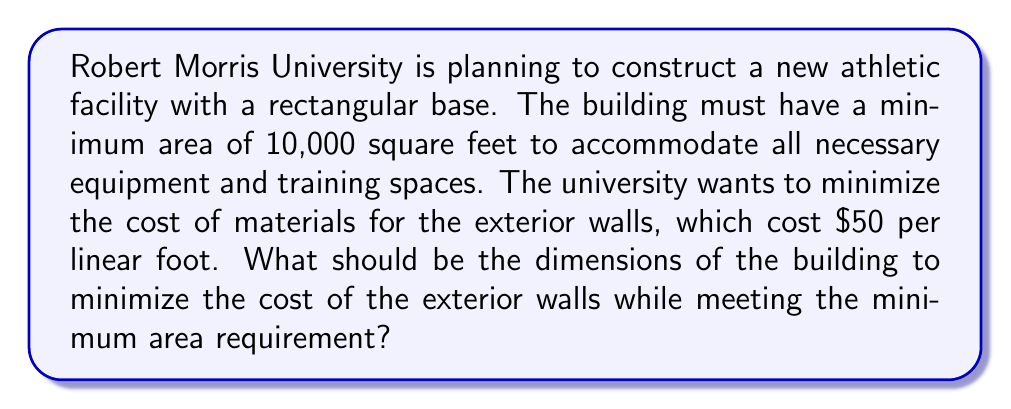Provide a solution to this math problem. Let's approach this step-by-step:

1) Let the length of the building be $l$ and the width be $w$.

2) The area constraint is:
   $$ A = l \cdot w \geq 10,000 \text{ sq ft} $$

3) The perimeter of the building (which determines the wall cost) is:
   $$ P = 2l + 2w $$

4) The cost function to minimize is:
   $$ C = 50P = 50(2l + 2w) = 100l + 100w $$

5) We want to minimize $C$ subject to the constraint $l \cdot w = 10,000$. 
   (We use equality here because the minimum will occur at the smallest possible area.)

6) We can use the method of Lagrange multipliers or substitute $w = \frac{10,000}{l}$ into the cost function:

   $$ C = 100l + 100(\frac{10,000}{l}) = 100l + \frac{1,000,000}{l} $$

7) To find the minimum, we differentiate and set to zero:

   $$ \frac{dC}{dl} = 100 - \frac{1,000,000}{l^2} = 0 $$

8) Solving this:
   $$ 100 = \frac{1,000,000}{l^2} $$
   $$ l^2 = 10,000 $$
   $$ l = 100 $$

9) Since $l \cdot w = 10,000$, we can find $w$:
   $$ w = \frac{10,000}{l} = \frac{10,000}{100} = 100 $$

Therefore, the optimal dimensions are 100 ft by 100 ft, creating a square building.
Answer: The optimal dimensions of the building are 100 feet by 100 feet. 